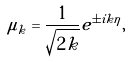<formula> <loc_0><loc_0><loc_500><loc_500>\mu _ { k } = \frac { 1 } { \sqrt { 2 k } } e ^ { \pm i k \eta } ,</formula> 